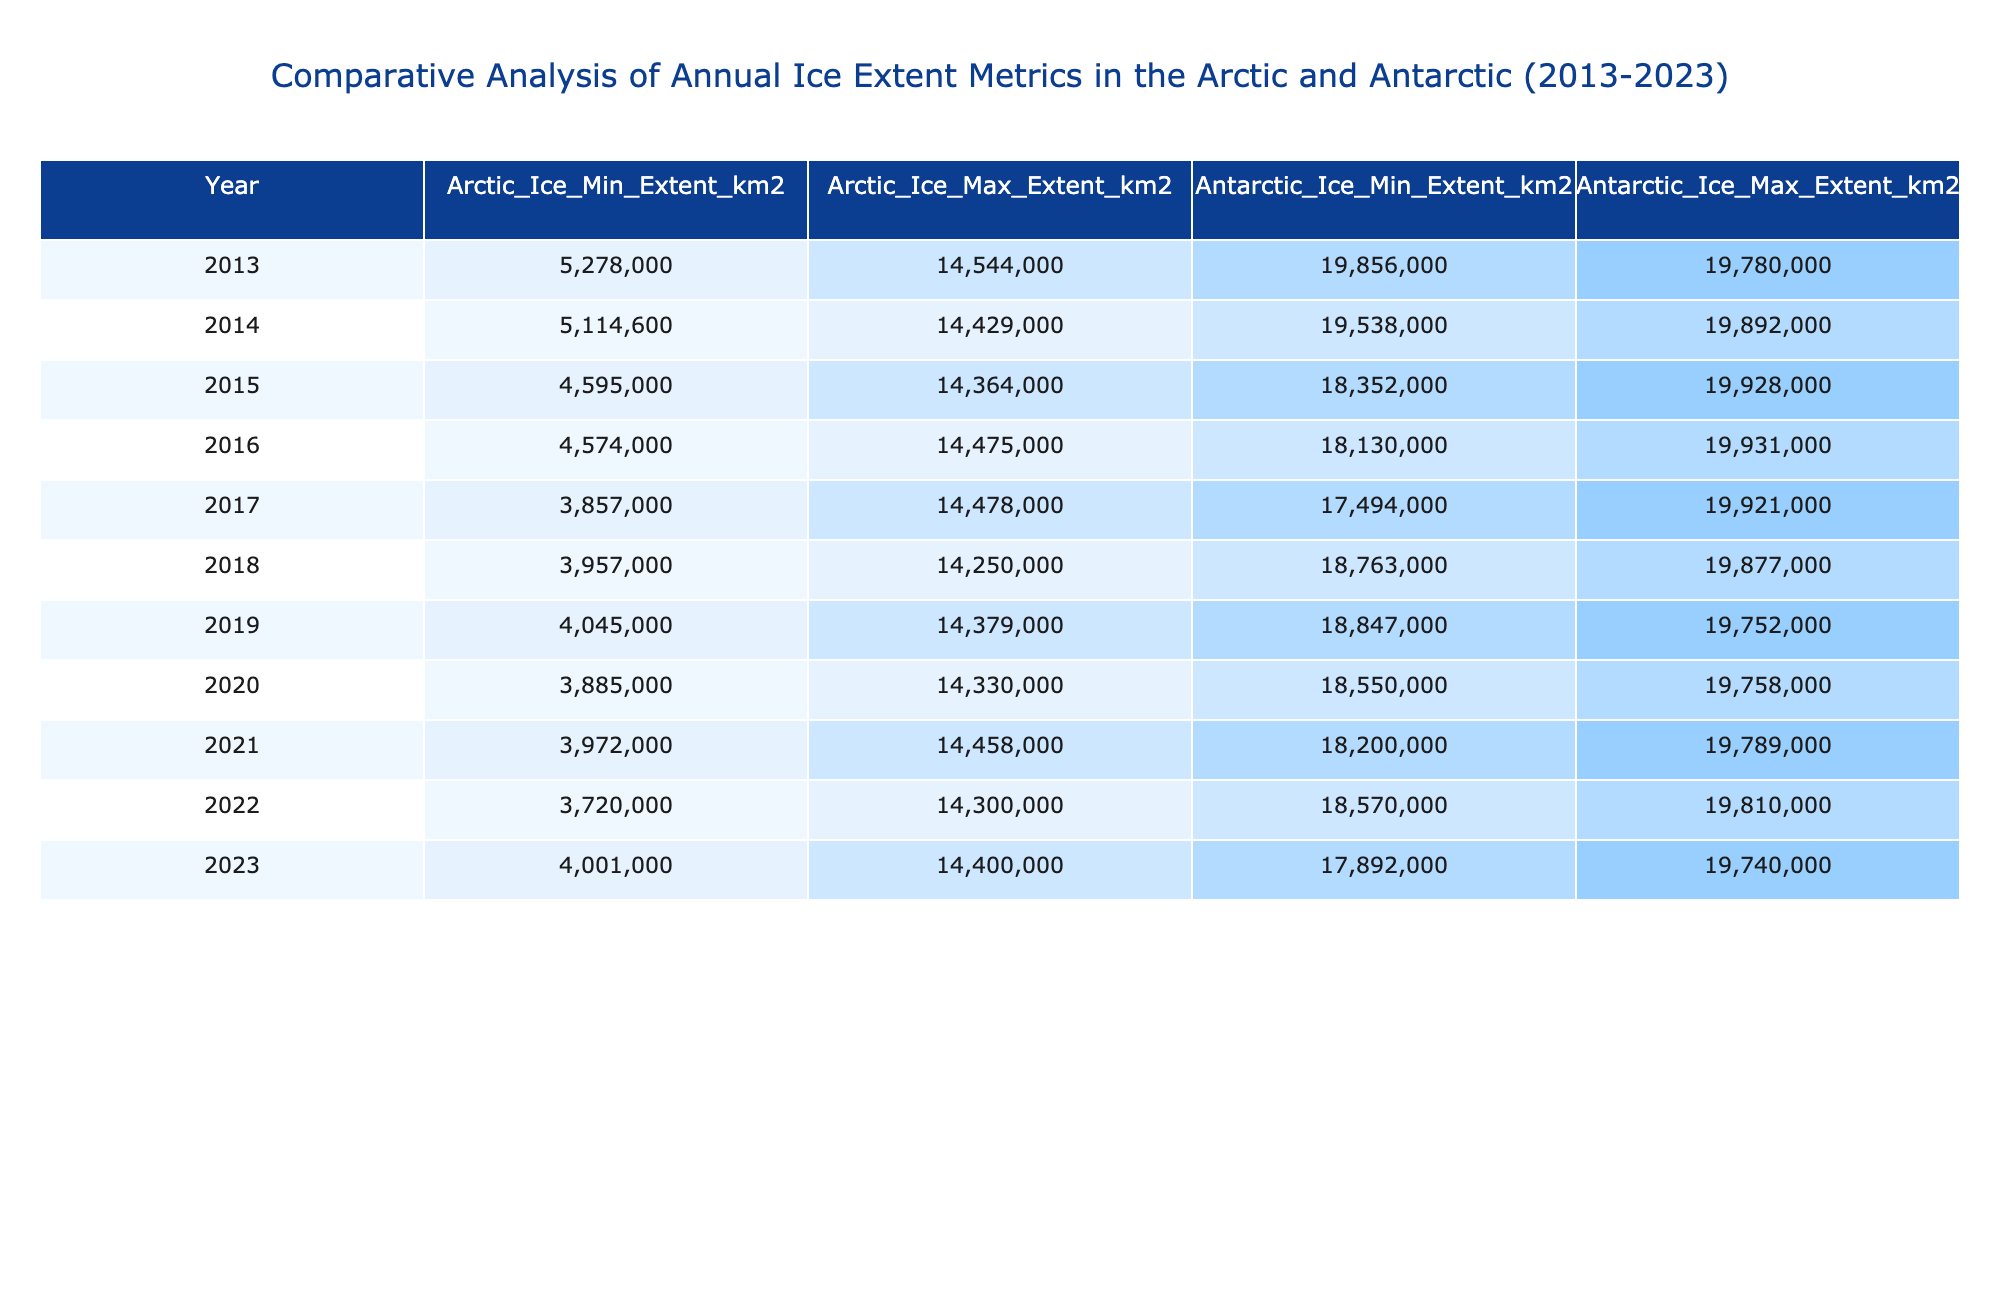What was the minimum Arctic ice extent in 2013? Referring to the table, the minimum Arctic ice extent for the year 2013 is listed as 5,278,000 km².
Answer: 5,278,000 km² What was the maximum Antarctic ice extent in 2020? The table shows the maximum Antarctic ice extent for 2020 as 19,758,000 km².
Answer: 19,758,000 km² Which year had the lowest minimum ice extent in the Arctic? By checking the minimum ice extent values, the year 2017 had the lowest minimum ice extent of 3,857,000 km².
Answer: 2017 What is the average maximum ice extent in the Arctic over the decade? The maximum values for the Arctic from 2013 to 2023 are added together (14,544,000 + 14,429,000 + 14,364,000 + 14,475,000 + 14,478,000 + 14,250,000 + 14,379,000 + 14,330,000 + 14,458,000 + 14,300,000 = 144,389,000), and then divided by 11, resulting in an average of 13,990,818 km².
Answer: 13,990,818 km² Is it true that the minimum Antarctic ice extent decreased every year from 2013 to 2023? By examining the minimum Antarctic ice extent values year by year, it can be seen that while there are years of fluctuation, such as an increase from 2016 to 2017, the overall trend shows a decline from 2013 (19,856,000 km²) to 2023 (17,892,000 km²). Thus, the statement is false.
Answer: False What was the percentage decrease in the Arctic minimum ice extent from 2013 to 2022? To calculate the decrease: Start with 5,278,000 km² in 2013 and finish with 3,720,000 km² in 2022. The decrease is 5,278,000 - 3,720,000 = 1,558,000 km². Then calculate the percentage decrease by (1,558,000 / 5,278,000) * 100, which is about 29.5%.
Answer: 29.5% In which year did the Antarctic ice reach the highest maximum extent? The table indicates that the highest maximum Antarctic ice extent was in 2014, with 19,892,000 km².
Answer: 2014 What was the trend in Arctic minimum ice extent from 2013 to 2023? Looking at the values year by year, a noticeable downward trend is apparent from 5,278,000 km² in 2013 to 4,001,000 km² in 2023, indicating a significant decline overall.
Answer: Downward trend Which year had the smallest difference between maximum and minimum ice extent in the Arctic? The differences are calculated for each year: e.g., for 2013, it's 14,544,000 - 5,278,000 = 9,266,000 km²; the smallest difference was in 2022, which is 14,300,000 - 3,720,000 = 10,580,000 km², thus 2022 has the smallest difference.
Answer: 2022 Was there a year when the Antarctic minimum ice extent was lower than 18 million km²? Checking the table, minimum Antarctic ice extent dropped below 18 million km² in both 2017 (17,494,000 km²) and 2023 (17,892,000 km²). Thus, the answer is true.
Answer: True 